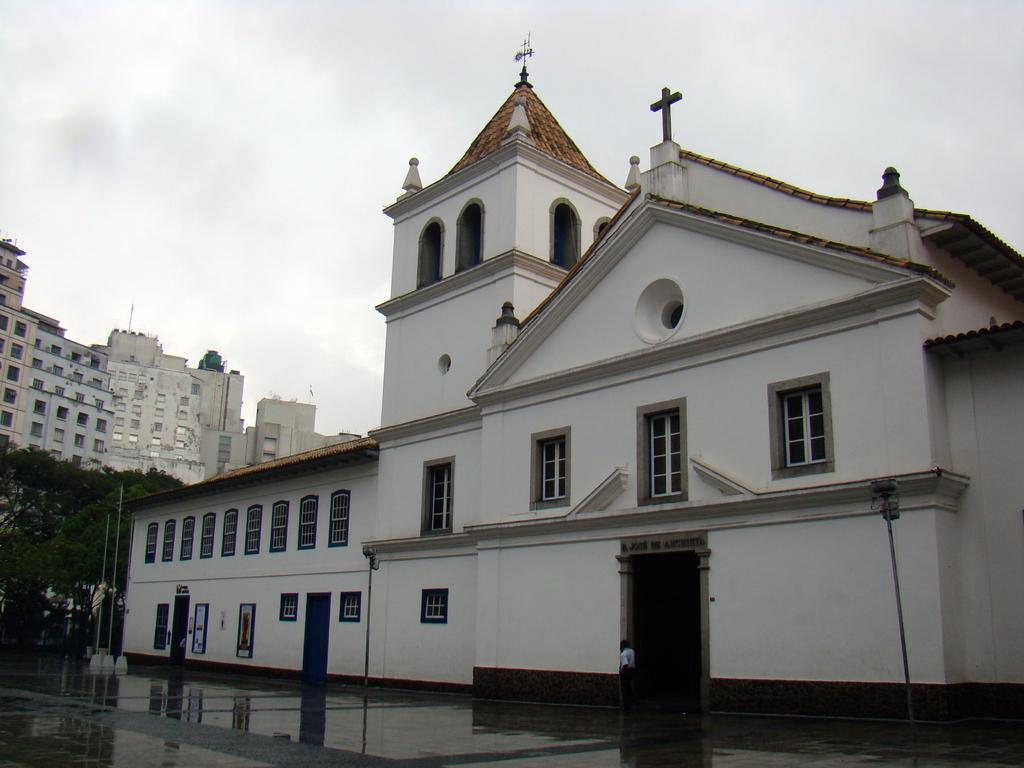What type of building can be seen in the image? There is a building in the image that resembles a church. What else can be seen on the left side of the image? There are other buildings visible on the left side of the image. What is visible in the background of the image? The sky is visible in the image. What type of natural elements are present in the image? Trees are present in the image. How many chairs are placed near the river in the image? There is no river or chairs present in the image. 